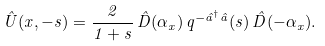Convert formula to latex. <formula><loc_0><loc_0><loc_500><loc_500>\hat { U } ( { x } , - s ) = \frac { 2 } { 1 + s } \, \hat { D } ( \alpha _ { x } ) \, q ^ { - \hat { a } ^ { \dagger } \hat { a } } ( s ) \, \hat { D } ( - \alpha _ { x } ) .</formula> 